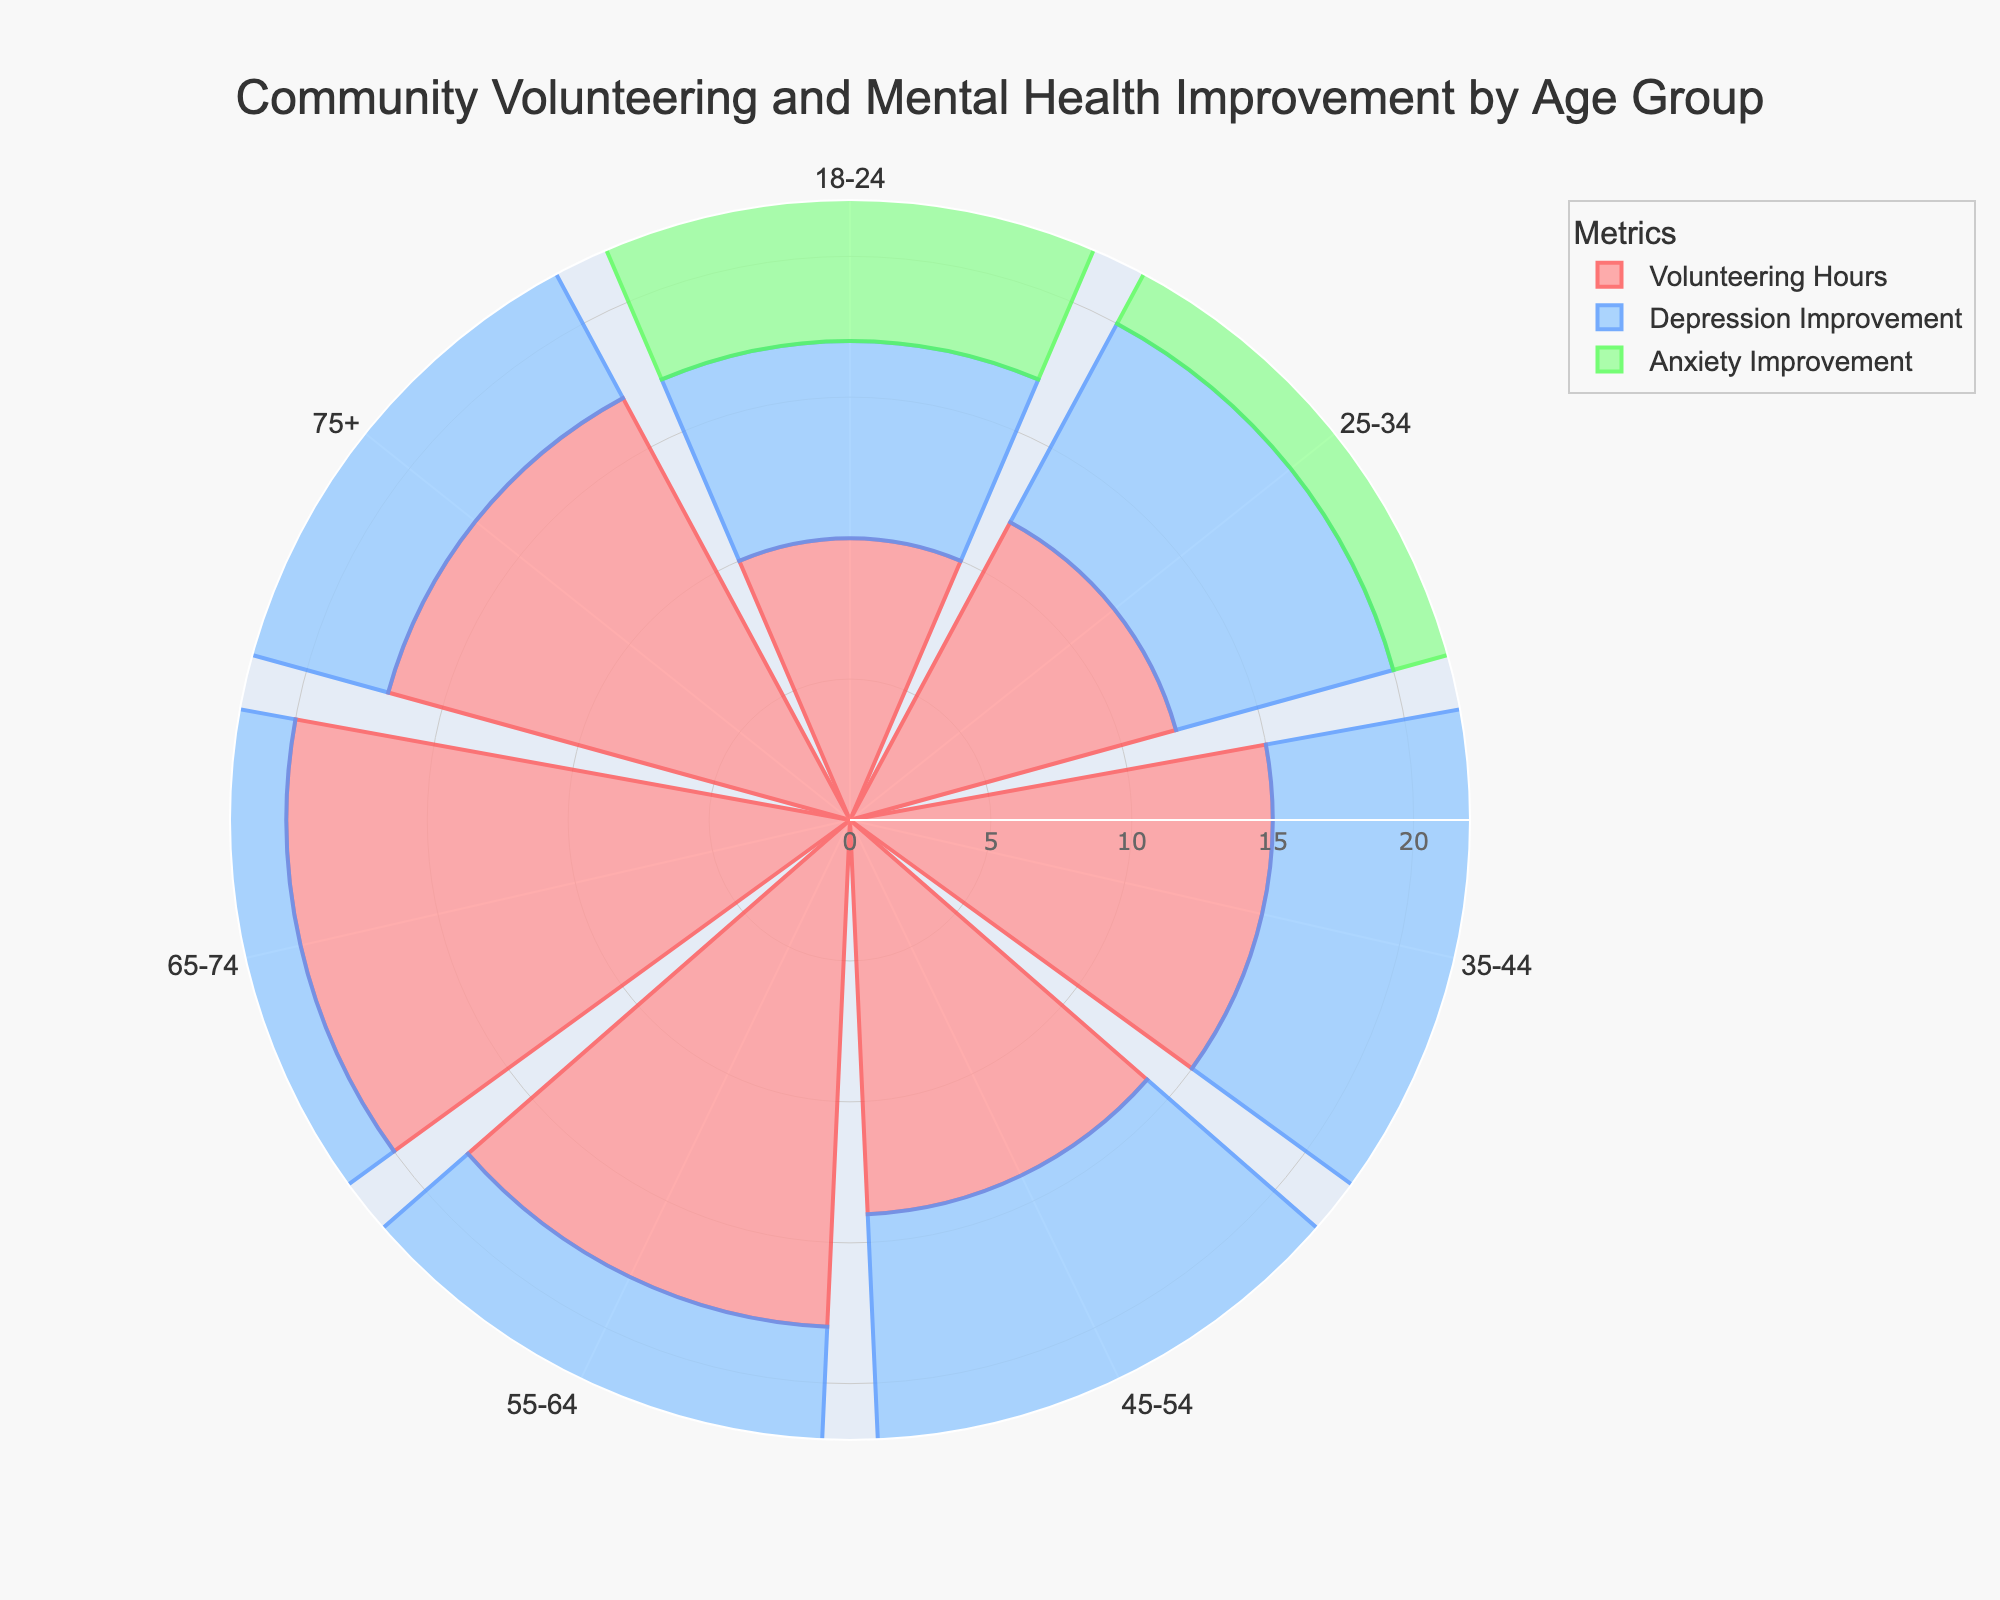What's the title of the figure? The title is often located at the top of the figure and provides a summarized description of what the figure is about. In this case, it is "Community Volunteering and Mental Health Improvement by Age Group".
Answer: Community Volunteering and Mental Health Improvement by Age Group What age group has the highest average volunteering hours? To determine this, look at the “Volunteering Hours” bars and identify which has the largest radial distance from the center. The age group 65-74 has the highest length indicating the most volunteering hours.
Answer: 65-74 Which age group has the highest depression improvement score? By examining the “Depression Improvement” bars, we can see that the bar with the longest radial distance corresponds to the age group 75+.
Answer: 75+ How do volunteering hours correlate with depression improvement across age groups? To answer this, we must compare the lengths of the “Volunteering Hours” bars with the “Depression Improvement” bars across all age groups. There seems to be a general trend where higher volunteer hours correspond to higher depression improvement scores, with 75+ being an exception with higher improvement despite lower hours.
Answer: Generally positive correlation What is the difference in average volunteering hours between the 55-64 and 18-24 age groups? The average volunteering hours for age group 55-64 is 18 hours, whereas for 18-24 it is 10 hours. The difference is 18 - 10.
Answer: 8 hours Which age group has both high volunteering hours and high anxiety improvement scores? Analyzing both sets of bars for “Volunteering Hours” and “Anxiety Improvement,” the age group 65-74 stands out with high values in both metrics.
Answer: 65-74 Compare the anxiety improvement scores for the age groups 25-34 and 55-64? The anxiety improvement score for the age group 25-34 is 7, while for the 55-64 group it is 10. Comparing these, 55-64 has a higher score.
Answer: 55-64 has a higher score What is the range of average volunteering hours across all age groups? The shortest “Volunteering Hours” bar is for 18-24 with 10 hours, and the longest is for 65-74 with 20 hours. The range is thus 20 - 10.
Answer: 10 hours What is the relationship between age and mental health improvement? Observing the lengths of both “Depression” and “Anxiety Improvement” bars, we notice that generally, older age groups show higher improvement scores.
Answer: Generally, older age groups show better improvement Is there any age group with higher anxiety improvement than depression improvement? By inspecting the lengths of both “Anxiety Improvement” and “Depression Improvement” bars for each age group, all age groups show higher depression improvement scores than anxiety improvement scores.
Answer: No 